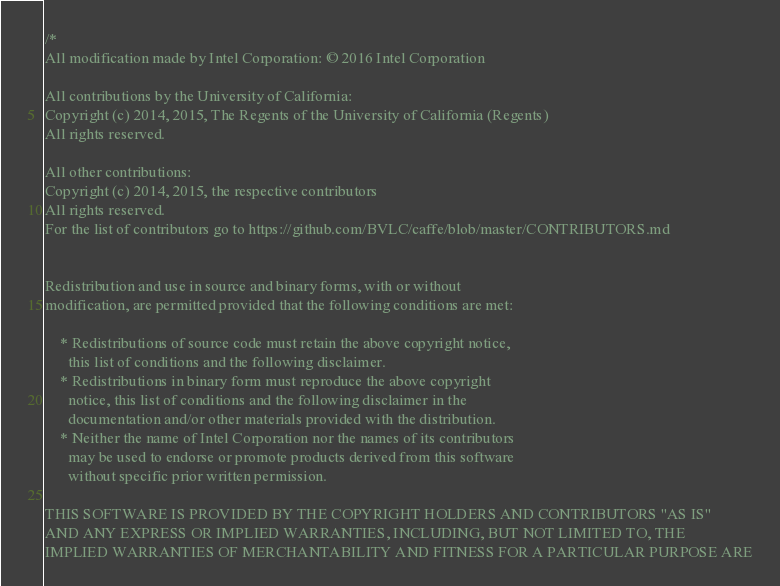<code> <loc_0><loc_0><loc_500><loc_500><_Cuda_>/*
All modification made by Intel Corporation: © 2016 Intel Corporation

All contributions by the University of California:
Copyright (c) 2014, 2015, The Regents of the University of California (Regents)
All rights reserved.

All other contributions:
Copyright (c) 2014, 2015, the respective contributors
All rights reserved.
For the list of contributors go to https://github.com/BVLC/caffe/blob/master/CONTRIBUTORS.md


Redistribution and use in source and binary forms, with or without
modification, are permitted provided that the following conditions are met:

    * Redistributions of source code must retain the above copyright notice,
      this list of conditions and the following disclaimer.
    * Redistributions in binary form must reproduce the above copyright
      notice, this list of conditions and the following disclaimer in the
      documentation and/or other materials provided with the distribution.
    * Neither the name of Intel Corporation nor the names of its contributors
      may be used to endorse or promote products derived from this software
      without specific prior written permission.

THIS SOFTWARE IS PROVIDED BY THE COPYRIGHT HOLDERS AND CONTRIBUTORS "AS IS"
AND ANY EXPRESS OR IMPLIED WARRANTIES, INCLUDING, BUT NOT LIMITED TO, THE
IMPLIED WARRANTIES OF MERCHANTABILITY AND FITNESS FOR A PARTICULAR PURPOSE ARE</code> 